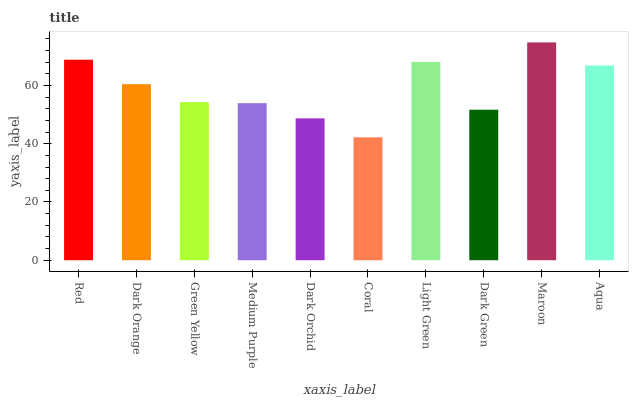Is Maroon the maximum?
Answer yes or no. Yes. Is Dark Orange the minimum?
Answer yes or no. No. Is Dark Orange the maximum?
Answer yes or no. No. Is Red greater than Dark Orange?
Answer yes or no. Yes. Is Dark Orange less than Red?
Answer yes or no. Yes. Is Dark Orange greater than Red?
Answer yes or no. No. Is Red less than Dark Orange?
Answer yes or no. No. Is Dark Orange the high median?
Answer yes or no. Yes. Is Green Yellow the low median?
Answer yes or no. Yes. Is Maroon the high median?
Answer yes or no. No. Is Dark Orchid the low median?
Answer yes or no. No. 